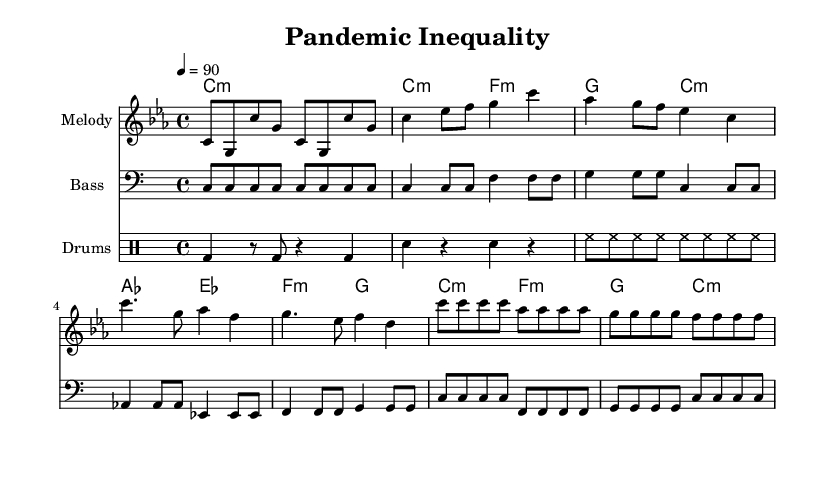What is the key signature of this music? The key signature is C minor, which is indicated by three flats in the key signature box.
Answer: C minor What is the time signature of this sheet music? The time signature is 4/4, as noted at the beginning of the sheet music next to the clef.
Answer: 4/4 What is the tempo marking for this piece? The tempo marking is placed above the staff, indicating a speed of 90 beats per minute.
Answer: 90 What is the harmonic progression in the verse? The verse harmonically moves from C minor to F minor, then to G, and resolves back to C minor, as noted in the chord mode section.
Answer: C minor, F minor, G, C minor What type of rhythm dominates the drum patterns in this piece? The drum patterns include a combination of bass drum, snare drum, and hi-hat rhythms, typical for rap beats, characterized by their repetitive and driving nature.
Answer: Bass, snare, hi-hat How many measures are there in the chorus section? The chorus consists of four measures, as indicated by the grouped notes and rhythmic patterns specific to this section.
Answer: 4 What is the overall mood conveyed by this rap piece? The overall mood is socially conscious, reflecting on economic inequalities, as indicated by the choice of lyrics and musical arrangement.
Answer: Socially conscious 